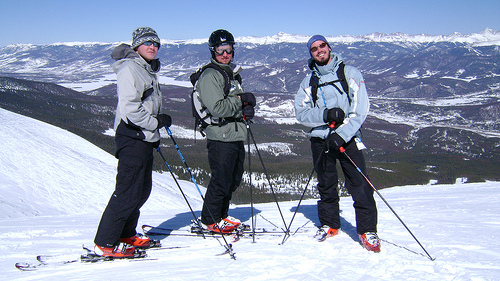Describe the overall atmosphere and mood conveyed by this winter scene. The atmosphere in this image is exhilarating and serene, characterized by the vast snowy landscape and bright, clear skies. The presence of skiers adds a sense of adventure and recreation. 